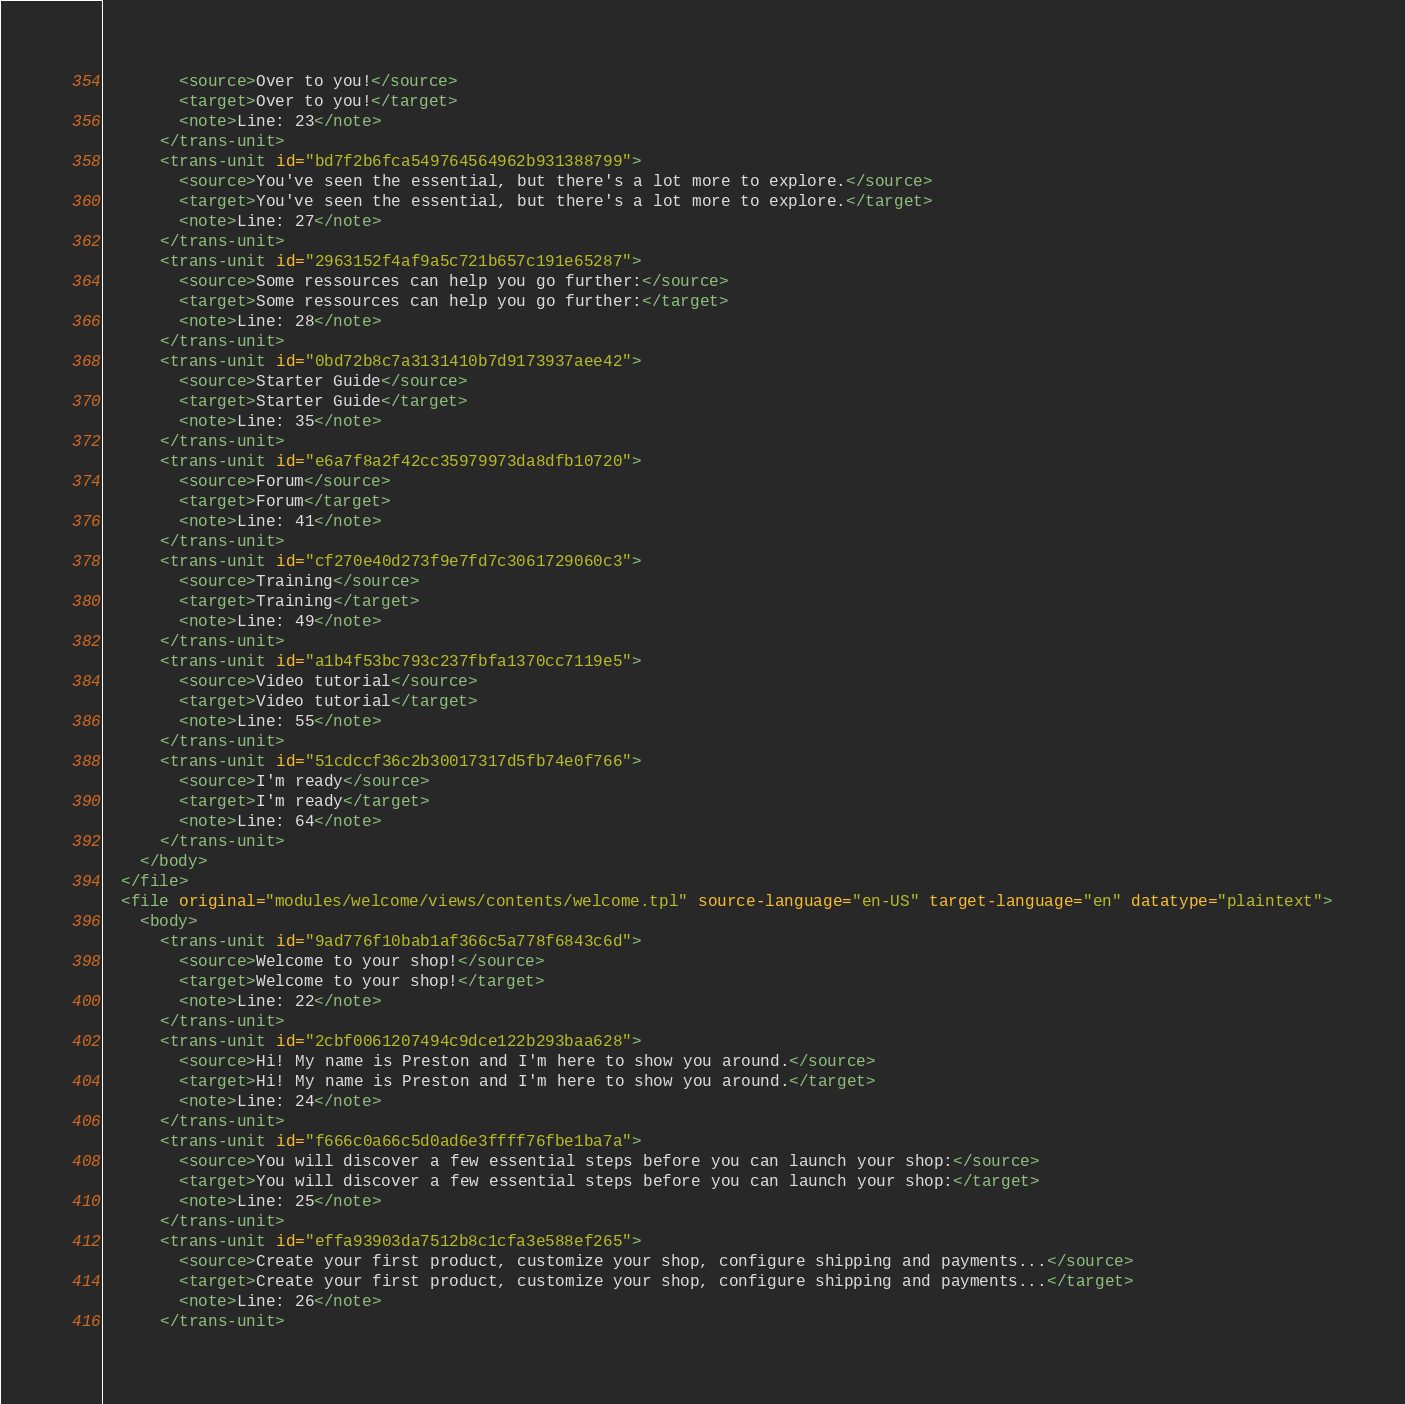Convert code to text. <code><loc_0><loc_0><loc_500><loc_500><_XML_>        <source>Over to you!</source>
        <target>Over to you!</target>
        <note>Line: 23</note>
      </trans-unit>
      <trans-unit id="bd7f2b6fca549764564962b931388799">
        <source>You've seen the essential, but there's a lot more to explore.</source>
        <target>You've seen the essential, but there's a lot more to explore.</target>
        <note>Line: 27</note>
      </trans-unit>
      <trans-unit id="2963152f4af9a5c721b657c191e65287">
        <source>Some ressources can help you go further:</source>
        <target>Some ressources can help you go further:</target>
        <note>Line: 28</note>
      </trans-unit>
      <trans-unit id="0bd72b8c7a3131410b7d9173937aee42">
        <source>Starter Guide</source>
        <target>Starter Guide</target>
        <note>Line: 35</note>
      </trans-unit>
      <trans-unit id="e6a7f8a2f42cc35979973da8dfb10720">
        <source>Forum</source>
        <target>Forum</target>
        <note>Line: 41</note>
      </trans-unit>
      <trans-unit id="cf270e40d273f9e7fd7c3061729060c3">
        <source>Training</source>
        <target>Training</target>
        <note>Line: 49</note>
      </trans-unit>
      <trans-unit id="a1b4f53bc793c237fbfa1370cc7119e5">
        <source>Video tutorial</source>
        <target>Video tutorial</target>
        <note>Line: 55</note>
      </trans-unit>
      <trans-unit id="51cdccf36c2b30017317d5fb74e0f766">
        <source>I'm ready</source>
        <target>I'm ready</target>
        <note>Line: 64</note>
      </trans-unit>
    </body>
  </file>
  <file original="modules/welcome/views/contents/welcome.tpl" source-language="en-US" target-language="en" datatype="plaintext">
    <body>
      <trans-unit id="9ad776f10bab1af366c5a778f6843c6d">
        <source>Welcome to your shop!</source>
        <target>Welcome to your shop!</target>
        <note>Line: 22</note>
      </trans-unit>
      <trans-unit id="2cbf0061207494c9dce122b293baa628">
        <source>Hi! My name is Preston and I'm here to show you around.</source>
        <target>Hi! My name is Preston and I'm here to show you around.</target>
        <note>Line: 24</note>
      </trans-unit>
      <trans-unit id="f666c0a66c5d0ad6e3ffff76fbe1ba7a">
        <source>You will discover a few essential steps before you can launch your shop:</source>
        <target>You will discover a few essential steps before you can launch your shop:</target>
        <note>Line: 25</note>
      </trans-unit>
      <trans-unit id="effa93903da7512b8c1cfa3e588ef265">
        <source>Create your first product, customize your shop, configure shipping and payments...</source>
        <target>Create your first product, customize your shop, configure shipping and payments...</target>
        <note>Line: 26</note>
      </trans-unit></code> 